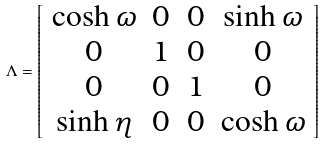<formula> <loc_0><loc_0><loc_500><loc_500>\Lambda = \left [ \begin{array} { c c c c } \cosh \omega & 0 & 0 & \sinh \omega \\ 0 & 1 & 0 & 0 \\ 0 & 0 & 1 & 0 \\ \sinh \eta & 0 & 0 & \cosh \omega \end{array} \right ]</formula> 